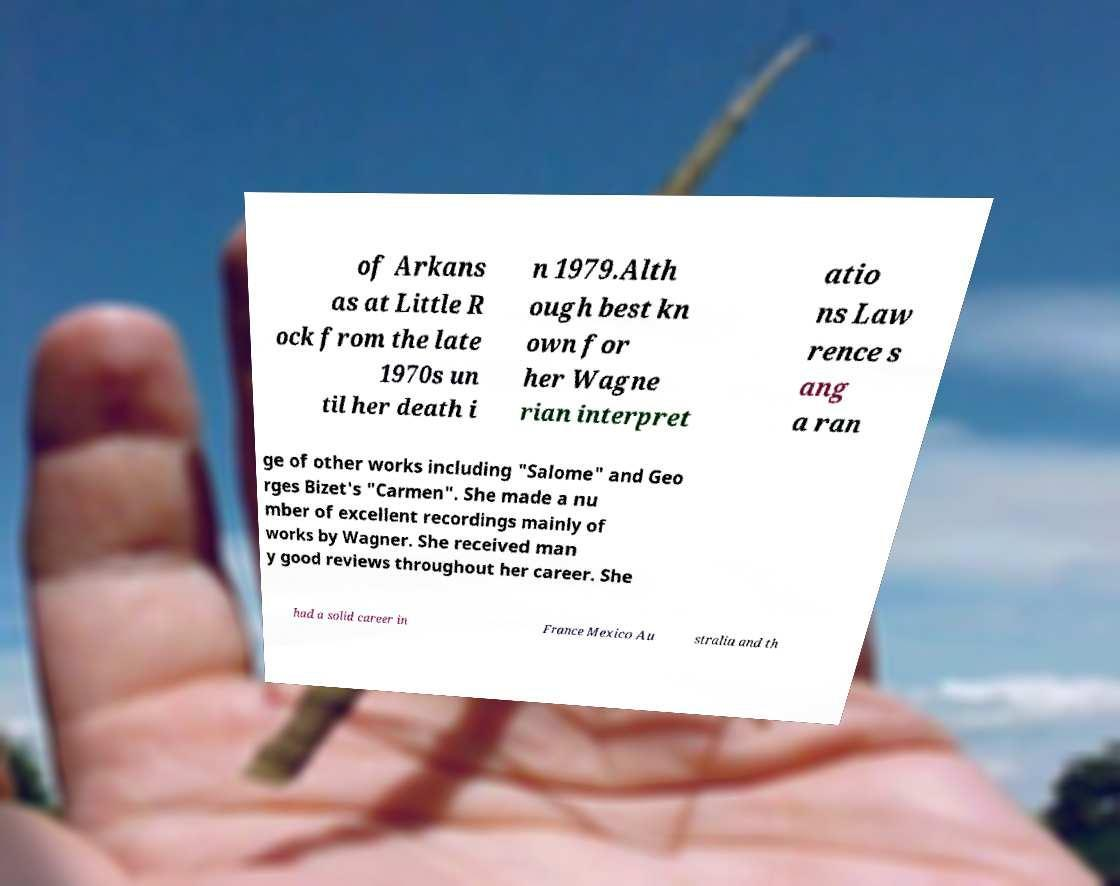For documentation purposes, I need the text within this image transcribed. Could you provide that? of Arkans as at Little R ock from the late 1970s un til her death i n 1979.Alth ough best kn own for her Wagne rian interpret atio ns Law rence s ang a ran ge of other works including "Salome" and Geo rges Bizet's "Carmen". She made a nu mber of excellent recordings mainly of works by Wagner. She received man y good reviews throughout her career. She had a solid career in France Mexico Au stralia and th 